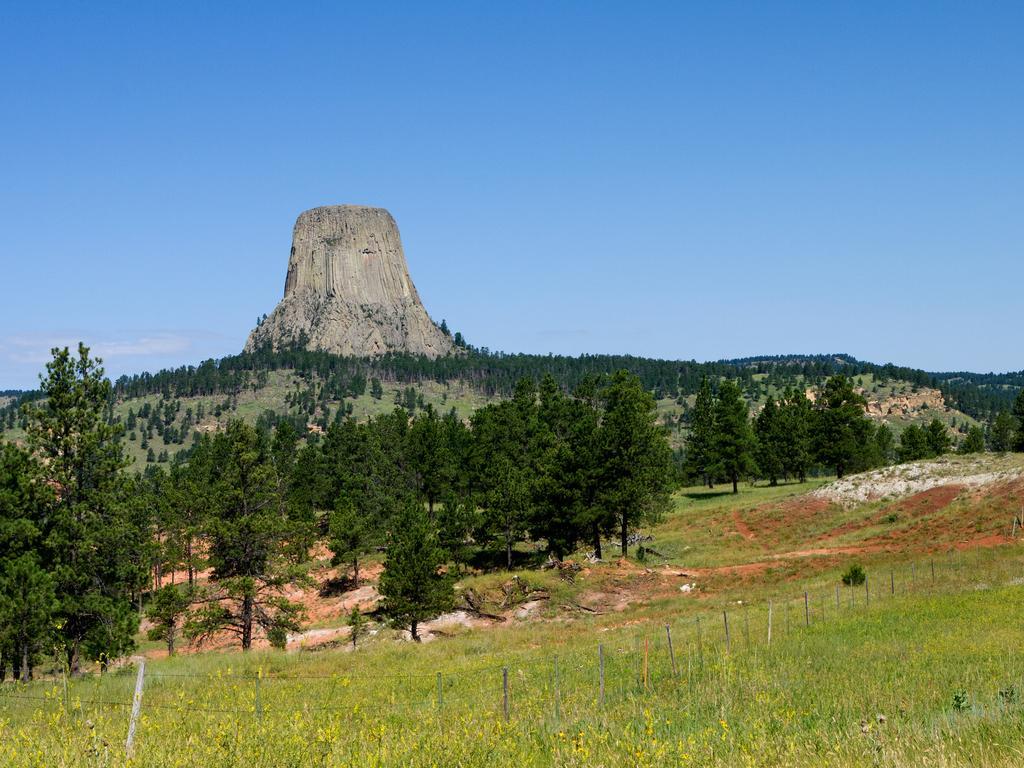Could you give a brief overview of what you see in this image? I can see trees fence, grass and mountain. In the background I can see the sky. 